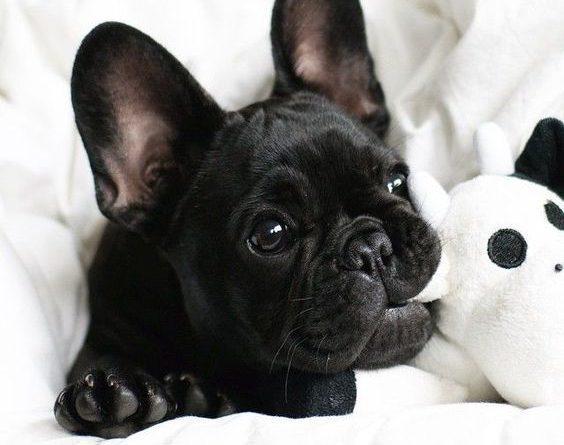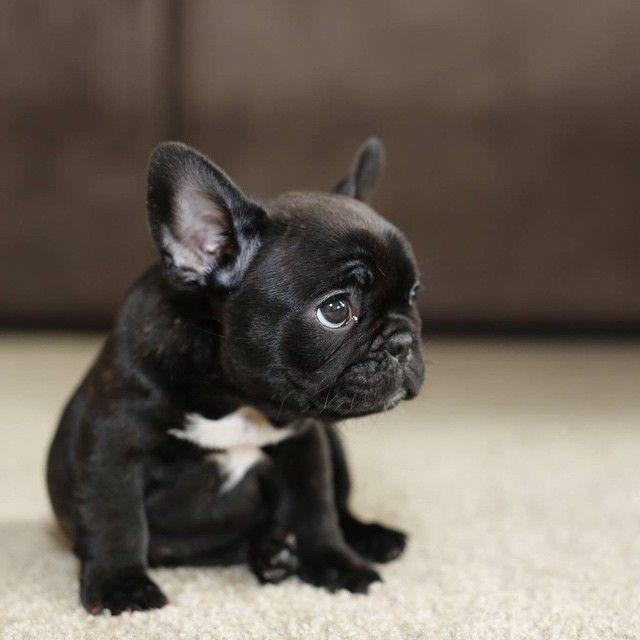The first image is the image on the left, the second image is the image on the right. Given the left and right images, does the statement "There are twp puppies in the image pair." hold true? Answer yes or no. Yes. The first image is the image on the left, the second image is the image on the right. Assess this claim about the two images: "Each image contains a single pug puppy, and each dog's gaze is in the same general direction.". Correct or not? Answer yes or no. Yes. 